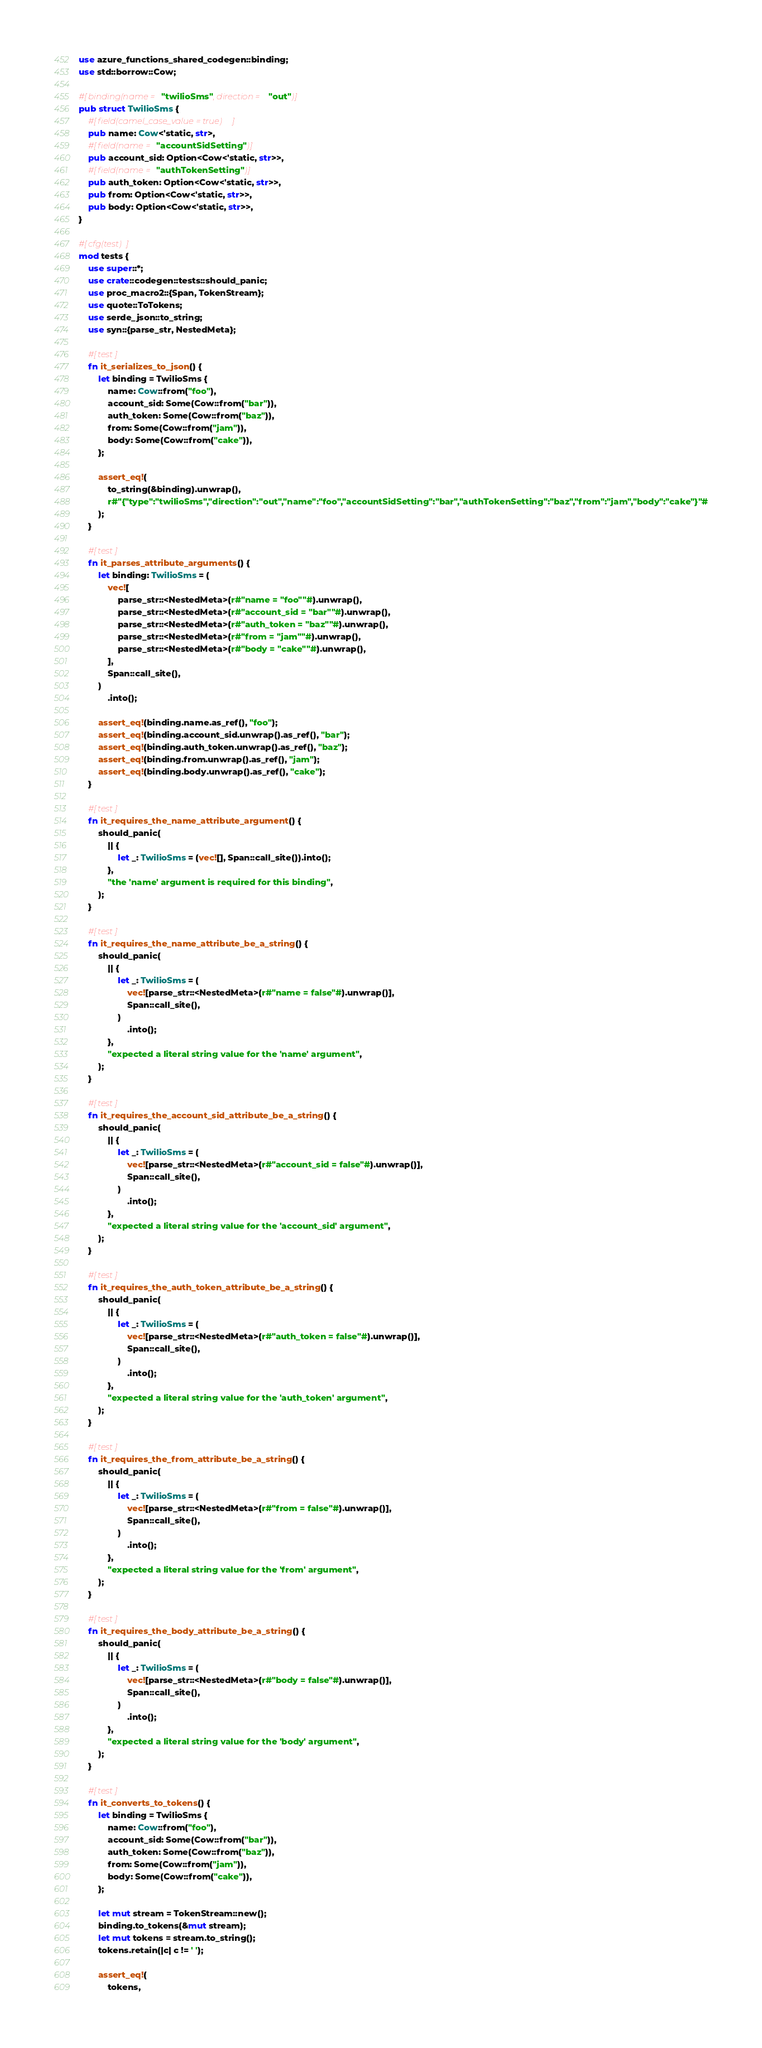<code> <loc_0><loc_0><loc_500><loc_500><_Rust_>use azure_functions_shared_codegen::binding;
use std::borrow::Cow;

#[binding(name = "twilioSms", direction = "out")]
pub struct TwilioSms {
    #[field(camel_case_value = true)]
    pub name: Cow<'static, str>,
    #[field(name = "accountSidSetting")]
    pub account_sid: Option<Cow<'static, str>>,
    #[field(name = "authTokenSetting")]
    pub auth_token: Option<Cow<'static, str>>,
    pub from: Option<Cow<'static, str>>,
    pub body: Option<Cow<'static, str>>,
}

#[cfg(test)]
mod tests {
    use super::*;
    use crate::codegen::tests::should_panic;
    use proc_macro2::{Span, TokenStream};
    use quote::ToTokens;
    use serde_json::to_string;
    use syn::{parse_str, NestedMeta};

    #[test]
    fn it_serializes_to_json() {
        let binding = TwilioSms {
            name: Cow::from("foo"),
            account_sid: Some(Cow::from("bar")),
            auth_token: Some(Cow::from("baz")),
            from: Some(Cow::from("jam")),
            body: Some(Cow::from("cake")),
        };

        assert_eq!(
            to_string(&binding).unwrap(),
            r#"{"type":"twilioSms","direction":"out","name":"foo","accountSidSetting":"bar","authTokenSetting":"baz","from":"jam","body":"cake"}"#
        );
    }

    #[test]
    fn it_parses_attribute_arguments() {
        let binding: TwilioSms = (
            vec![
                parse_str::<NestedMeta>(r#"name = "foo""#).unwrap(),
                parse_str::<NestedMeta>(r#"account_sid = "bar""#).unwrap(),
                parse_str::<NestedMeta>(r#"auth_token = "baz""#).unwrap(),
                parse_str::<NestedMeta>(r#"from = "jam""#).unwrap(),
                parse_str::<NestedMeta>(r#"body = "cake""#).unwrap(),
            ],
            Span::call_site(),
        )
            .into();

        assert_eq!(binding.name.as_ref(), "foo");
        assert_eq!(binding.account_sid.unwrap().as_ref(), "bar");
        assert_eq!(binding.auth_token.unwrap().as_ref(), "baz");
        assert_eq!(binding.from.unwrap().as_ref(), "jam");
        assert_eq!(binding.body.unwrap().as_ref(), "cake");
    }

    #[test]
    fn it_requires_the_name_attribute_argument() {
        should_panic(
            || {
                let _: TwilioSms = (vec![], Span::call_site()).into();
            },
            "the 'name' argument is required for this binding",
        );
    }

    #[test]
    fn it_requires_the_name_attribute_be_a_string() {
        should_panic(
            || {
                let _: TwilioSms = (
                    vec![parse_str::<NestedMeta>(r#"name = false"#).unwrap()],
                    Span::call_site(),
                )
                    .into();
            },
            "expected a literal string value for the 'name' argument",
        );
    }

    #[test]
    fn it_requires_the_account_sid_attribute_be_a_string() {
        should_panic(
            || {
                let _: TwilioSms = (
                    vec![parse_str::<NestedMeta>(r#"account_sid = false"#).unwrap()],
                    Span::call_site(),
                )
                    .into();
            },
            "expected a literal string value for the 'account_sid' argument",
        );
    }

    #[test]
    fn it_requires_the_auth_token_attribute_be_a_string() {
        should_panic(
            || {
                let _: TwilioSms = (
                    vec![parse_str::<NestedMeta>(r#"auth_token = false"#).unwrap()],
                    Span::call_site(),
                )
                    .into();
            },
            "expected a literal string value for the 'auth_token' argument",
        );
    }

    #[test]
    fn it_requires_the_from_attribute_be_a_string() {
        should_panic(
            || {
                let _: TwilioSms = (
                    vec![parse_str::<NestedMeta>(r#"from = false"#).unwrap()],
                    Span::call_site(),
                )
                    .into();
            },
            "expected a literal string value for the 'from' argument",
        );
    }

    #[test]
    fn it_requires_the_body_attribute_be_a_string() {
        should_panic(
            || {
                let _: TwilioSms = (
                    vec![parse_str::<NestedMeta>(r#"body = false"#).unwrap()],
                    Span::call_site(),
                )
                    .into();
            },
            "expected a literal string value for the 'body' argument",
        );
    }

    #[test]
    fn it_converts_to_tokens() {
        let binding = TwilioSms {
            name: Cow::from("foo"),
            account_sid: Some(Cow::from("bar")),
            auth_token: Some(Cow::from("baz")),
            from: Some(Cow::from("jam")),
            body: Some(Cow::from("cake")),
        };

        let mut stream = TokenStream::new();
        binding.to_tokens(&mut stream);
        let mut tokens = stream.to_string();
        tokens.retain(|c| c != ' ');

        assert_eq!(
            tokens,</code> 